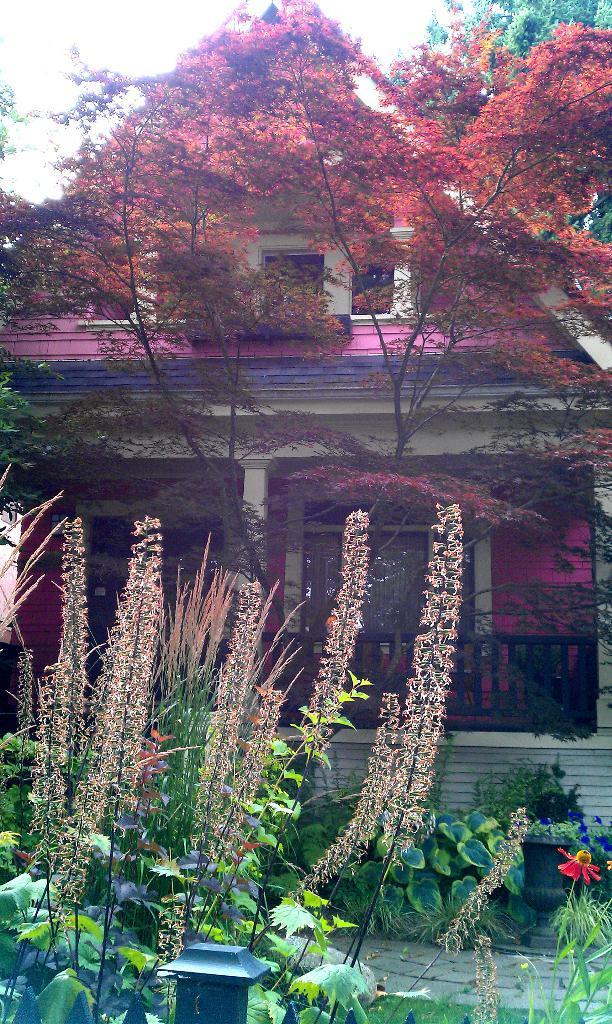Describe this image in one or two sentences. This picture might be taken from outside of the city. In this image, on the right side, we can see a plant with a flower which is in red color. On the left side, we can see some plants, leaves. In the middle of the image, we can see a pole. In the background, we can see a house, trees, glass window, pillars. At the top, we can see a sky, at the bottom there is a land and a grass. 